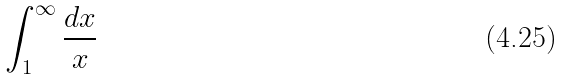<formula> <loc_0><loc_0><loc_500><loc_500>\int _ { 1 } ^ { \infty } \frac { d x } { x }</formula> 